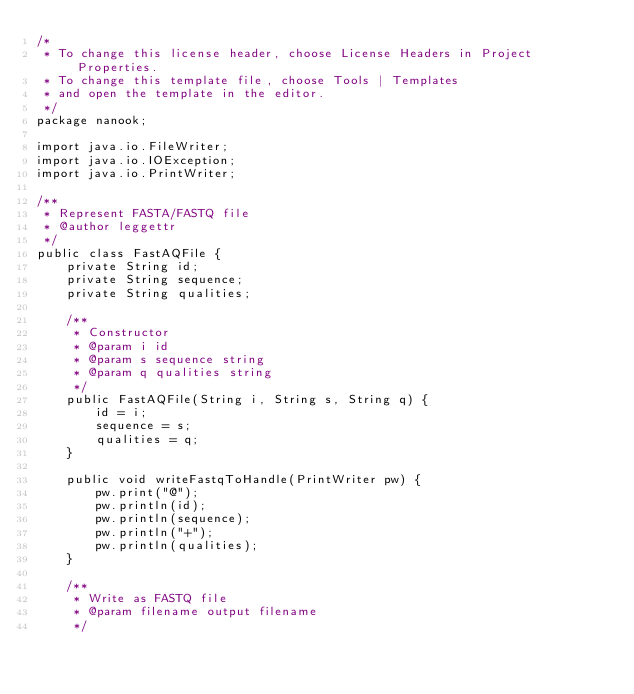<code> <loc_0><loc_0><loc_500><loc_500><_Java_>/*
 * To change this license header, choose License Headers in Project Properties.
 * To change this template file, choose Tools | Templates
 * and open the template in the editor.
 */
package nanook;

import java.io.FileWriter;
import java.io.IOException;
import java.io.PrintWriter;

/**
 * Represent FASTA/FASTQ file
 * @author leggettr
 */
public class FastAQFile {
    private String id;
    private String sequence;
    private String qualities;
    
    /**
     * Constructor
     * @param i id
     * @param s sequence string
     * @param q qualities string
     */
    public FastAQFile(String i, String s, String q) {
        id = i;
        sequence = s;
        qualities = q;
    }
    
    public void writeFastqToHandle(PrintWriter pw) {
        pw.print("@");
        pw.println(id);
        pw.println(sequence);
        pw.println("+");
        pw.println(qualities);
    }
    
    /**
     * Write as FASTQ file
     * @param filename output filename
     */</code> 